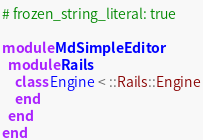<code> <loc_0><loc_0><loc_500><loc_500><_Ruby_># frozen_string_literal: true

module MdSimpleEditor
  module Rails
    class Engine < ::Rails::Engine
    end
  end
end
</code> 